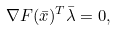Convert formula to latex. <formula><loc_0><loc_0><loc_500><loc_500>\nabla F ( \bar { x } ) ^ { T } \bar { \lambda } = 0 ,</formula> 